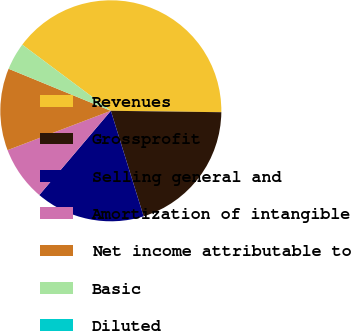Convert chart to OTSL. <chart><loc_0><loc_0><loc_500><loc_500><pie_chart><fcel>Revenues<fcel>Grossprofit<fcel>Selling general and<fcel>Amortization of intangible<fcel>Net income attributable to<fcel>Basic<fcel>Diluted<nl><fcel>40.0%<fcel>20.0%<fcel>16.0%<fcel>8.0%<fcel>12.0%<fcel>4.0%<fcel>0.0%<nl></chart> 